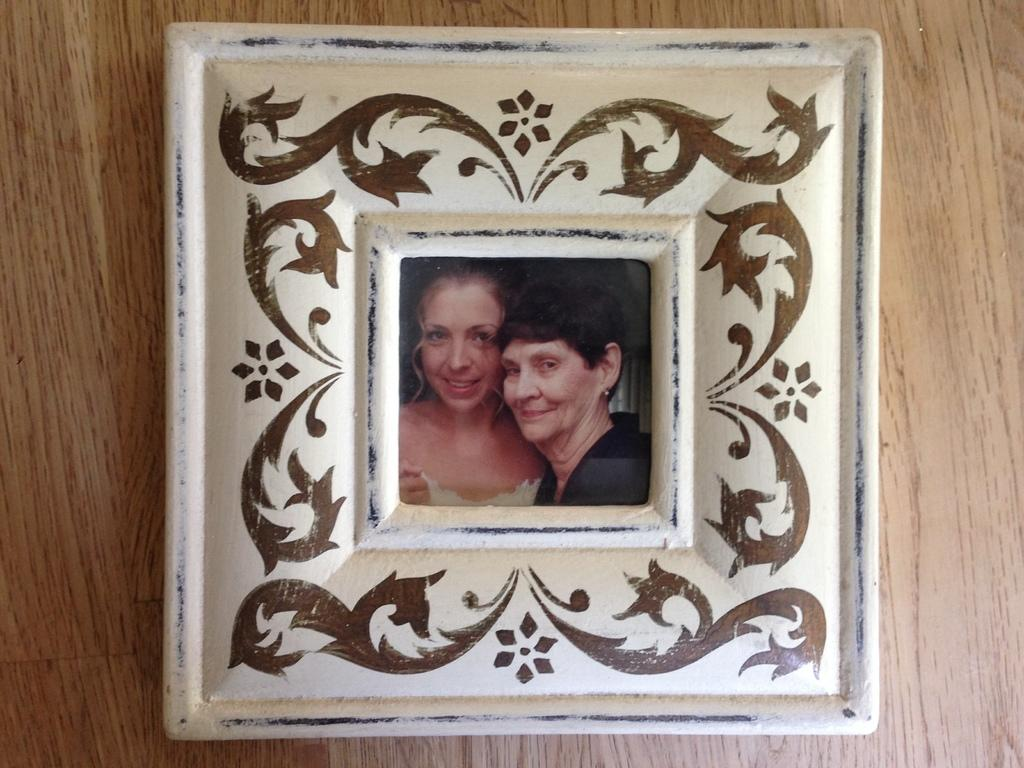What object is visible in the image? There is a photo frame in the image. Where is the photo frame located? The photo frame is placed on a wooden surface. How many horses are visible in the image? There are no horses present in the image; it only features a photo frame on a wooden surface. 